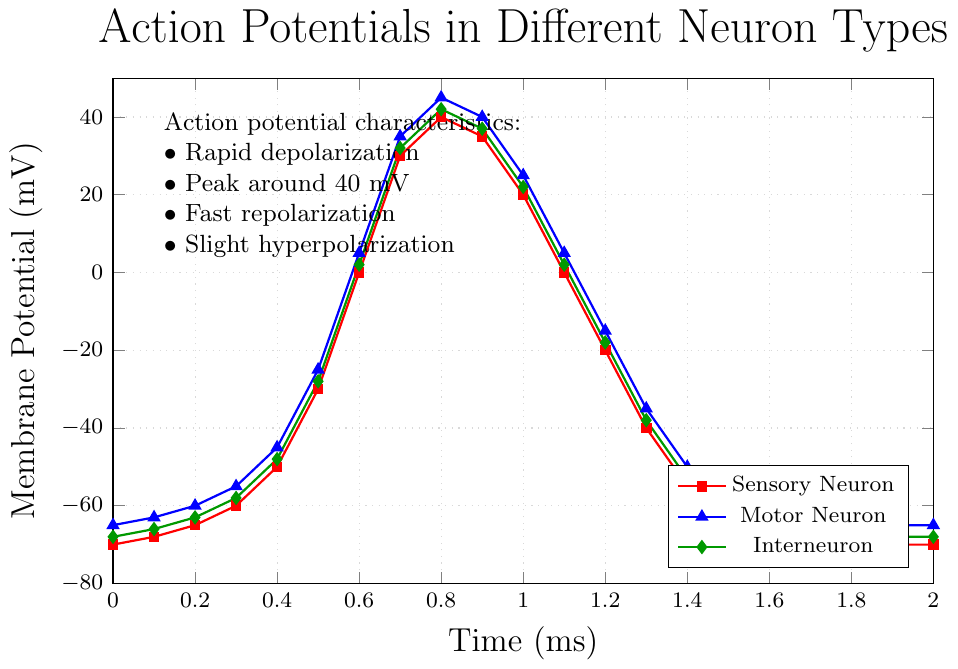What is the membrane potential of the sensory neuron at 0.9 ms? Refer to the curve for the sensory neuron (red line) at 0.9 ms and find the corresponding value on the y-axis. This value is 35 mV.
Answer: 35 mV Between the sensory neuron and the motor neuron, which one has a higher peak membrane potential and what is the value? Locate the peak points for both sensory (red) and motor (blue) neuron curves. The sensory neuron peaks at 40 mV, whereas the motor neuron peaks at 45 mV. Thus, the motor neuron has a higher peak of 45 mV.
Answer: Motor Neuron, 45 mV What is the difference in membrane potential between the motor neuron and the interneuron at 0.8 ms? Find the membrane potentials of both the motor neuron (blue) and interneuron (green) at 0.8 ms. The values are 45 mV for the motor neuron and 42 mV for the interneuron. The difference is 45 - 42 = 3 mV.
Answer: 3 mV At what time do all three neurons first reach values greater than 0 mV? Follow each curve and identify the time point at which all three values (sensory, motor, interneuron) surpass 0 mV. This occurs at 0.6 ms where the sensory neuron reaches 0 mV, motor neuron reaches 5 mV, and interneuron reaches 2 mV.
Answer: 0.6 ms Which neuron exhibits the fastest rate of depolarization and over which time interval does this occur? To determine the fastest rate of depolarization, look for the steepest slope in each neuron’s curve. Sensory neuron’s steepest rise is from -30 mV to 30 mV between 0.5 and 0.7 ms. Motor neuron climbs from -25 mV to 35 mV within the same interval, showing a greater change. Interneuron’s similar interval has a smaller difference. So the motor neuron depolarizes the fastest between 0.5 and 0.7 ms.
Answer: Motor Neuron, 0.5-0.7 ms What is the average peak membrane potential of all three neurons? Identify the peak values of the three neurons: Sensory neuron (40 mV), Motor neuron (45 mV), Interneuron (42 mV). Calculate the average: (40 + 45 + 42) / 3 = 42.33 mV.
Answer: 42.33 mV Between 1.0 ms and 1.4 ms, which neuron returns to its resting potential the fastest? Determine when each neuron returns to its resting potential after the peak. Sensory neuron goes from 20 mV (1.0 ms) to -55 mV (1.4 ms), Motor neuron from 25 mV (1.0 ms) to -50 mV (1.4 ms), Interneuron from 22 mV (1.0 ms) to -53 mV (1.4 ms). All show similar return times, but sensory neuron drops fastest.
Answer: Sensory Neuron What visual attribute indicates that the sensory neuron has the fastest repolarization rate? Assess the steepness of each curve's descent after their peaks. The sensory neuron's curve (red) shows the steepest drop from 0.8 ms to 1.4 ms compared to motor (blue) and interneuron (green).
Answer: Steepest slope 